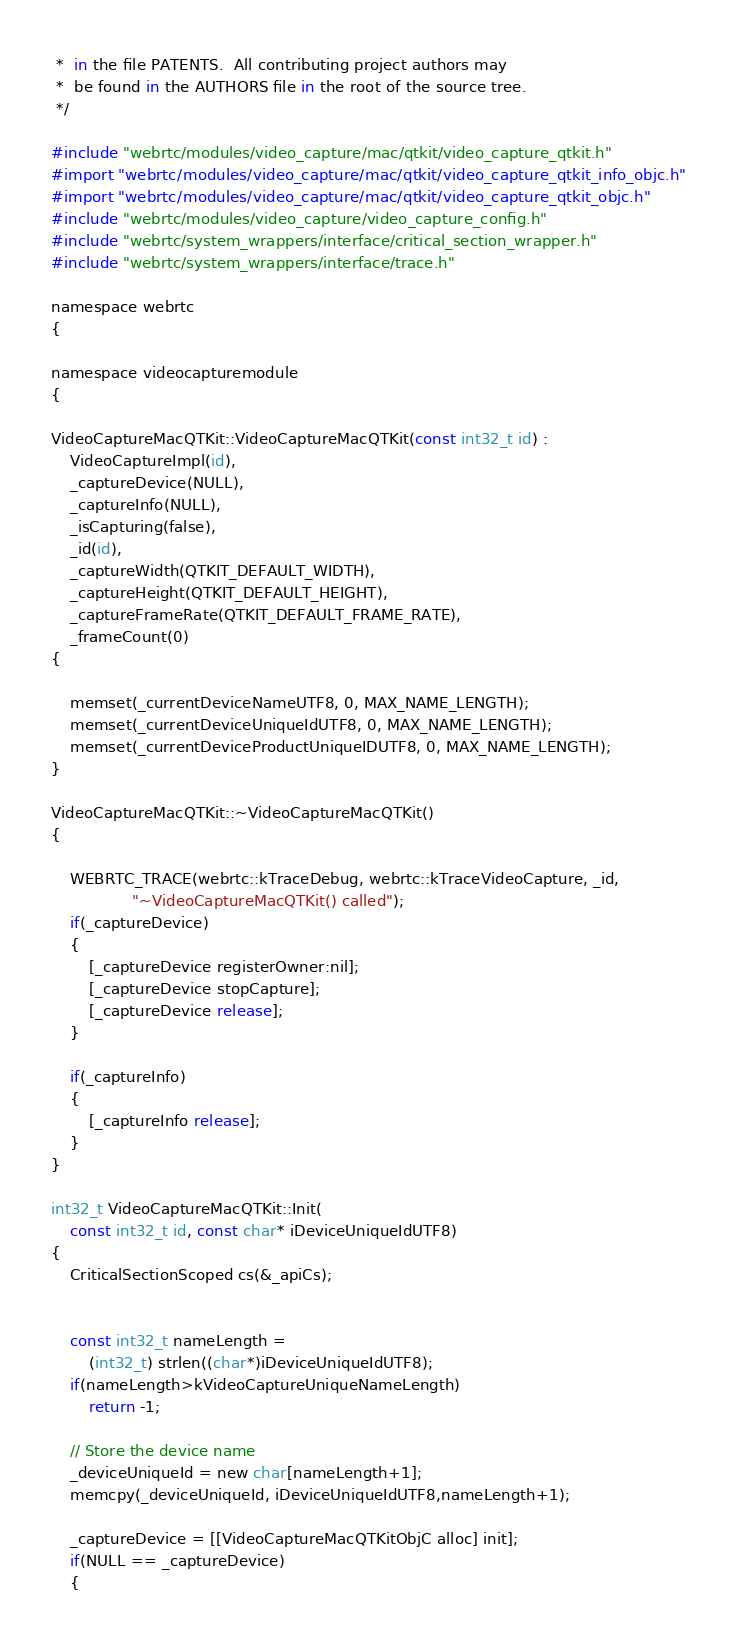Convert code to text. <code><loc_0><loc_0><loc_500><loc_500><_ObjectiveC_> *  in the file PATENTS.  All contributing project authors may
 *  be found in the AUTHORS file in the root of the source tree.
 */

#include "webrtc/modules/video_capture/mac/qtkit/video_capture_qtkit.h"
#import "webrtc/modules/video_capture/mac/qtkit/video_capture_qtkit_info_objc.h"
#import "webrtc/modules/video_capture/mac/qtkit/video_capture_qtkit_objc.h"
#include "webrtc/modules/video_capture/video_capture_config.h"
#include "webrtc/system_wrappers/interface/critical_section_wrapper.h"
#include "webrtc/system_wrappers/interface/trace.h"

namespace webrtc
{

namespace videocapturemodule
{

VideoCaptureMacQTKit::VideoCaptureMacQTKit(const int32_t id) :
    VideoCaptureImpl(id),
    _captureDevice(NULL),
    _captureInfo(NULL),
    _isCapturing(false),
    _id(id),
    _captureWidth(QTKIT_DEFAULT_WIDTH),
    _captureHeight(QTKIT_DEFAULT_HEIGHT),
    _captureFrameRate(QTKIT_DEFAULT_FRAME_RATE),
    _frameCount(0)
{

    memset(_currentDeviceNameUTF8, 0, MAX_NAME_LENGTH);
    memset(_currentDeviceUniqueIdUTF8, 0, MAX_NAME_LENGTH);
    memset(_currentDeviceProductUniqueIDUTF8, 0, MAX_NAME_LENGTH);
}

VideoCaptureMacQTKit::~VideoCaptureMacQTKit()
{

    WEBRTC_TRACE(webrtc::kTraceDebug, webrtc::kTraceVideoCapture, _id,
                 "~VideoCaptureMacQTKit() called");
    if(_captureDevice)
    {
        [_captureDevice registerOwner:nil];
        [_captureDevice stopCapture];
        [_captureDevice release];
    }

    if(_captureInfo)
    {
        [_captureInfo release];
    }
}

int32_t VideoCaptureMacQTKit::Init(
    const int32_t id, const char* iDeviceUniqueIdUTF8)
{
    CriticalSectionScoped cs(&_apiCs);


    const int32_t nameLength =
        (int32_t) strlen((char*)iDeviceUniqueIdUTF8);
    if(nameLength>kVideoCaptureUniqueNameLength)
        return -1;

    // Store the device name
    _deviceUniqueId = new char[nameLength+1];
    memcpy(_deviceUniqueId, iDeviceUniqueIdUTF8,nameLength+1);

    _captureDevice = [[VideoCaptureMacQTKitObjC alloc] init];
    if(NULL == _captureDevice)
    {</code> 